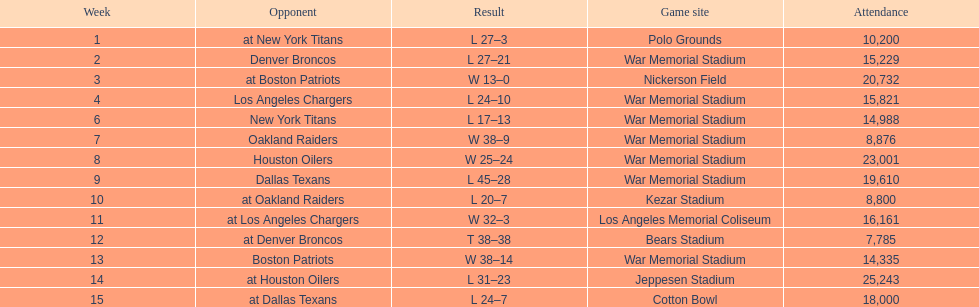What was the highest disparity in points during a single game? 29. 